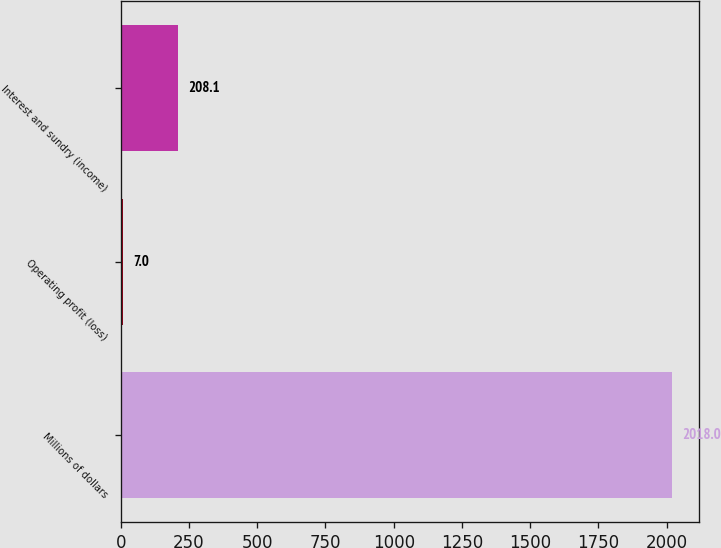Convert chart. <chart><loc_0><loc_0><loc_500><loc_500><bar_chart><fcel>Millions of dollars<fcel>Operating profit (loss)<fcel>Interest and sundry (income)<nl><fcel>2018<fcel>7<fcel>208.1<nl></chart> 